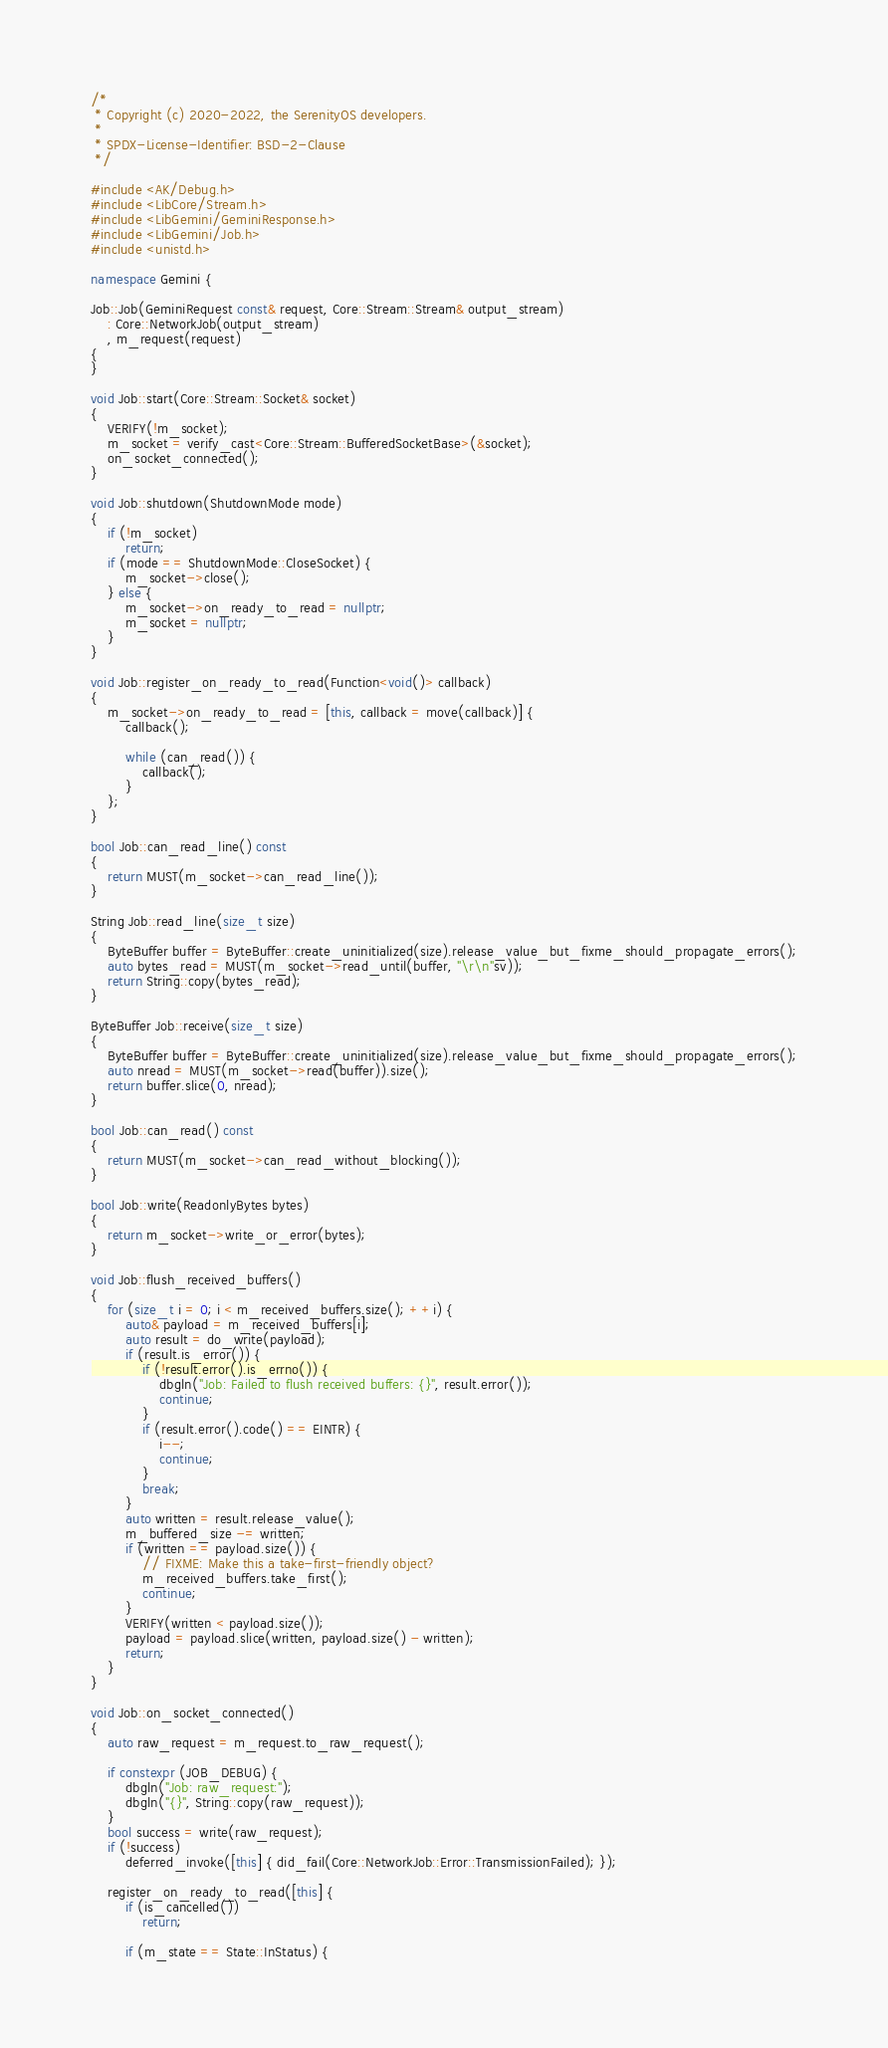<code> <loc_0><loc_0><loc_500><loc_500><_C++_>/*
 * Copyright (c) 2020-2022, the SerenityOS developers.
 *
 * SPDX-License-Identifier: BSD-2-Clause
 */

#include <AK/Debug.h>
#include <LibCore/Stream.h>
#include <LibGemini/GeminiResponse.h>
#include <LibGemini/Job.h>
#include <unistd.h>

namespace Gemini {

Job::Job(GeminiRequest const& request, Core::Stream::Stream& output_stream)
    : Core::NetworkJob(output_stream)
    , m_request(request)
{
}

void Job::start(Core::Stream::Socket& socket)
{
    VERIFY(!m_socket);
    m_socket = verify_cast<Core::Stream::BufferedSocketBase>(&socket);
    on_socket_connected();
}

void Job::shutdown(ShutdownMode mode)
{
    if (!m_socket)
        return;
    if (mode == ShutdownMode::CloseSocket) {
        m_socket->close();
    } else {
        m_socket->on_ready_to_read = nullptr;
        m_socket = nullptr;
    }
}

void Job::register_on_ready_to_read(Function<void()> callback)
{
    m_socket->on_ready_to_read = [this, callback = move(callback)] {
        callback();

        while (can_read()) {
            callback();
        }
    };
}

bool Job::can_read_line() const
{
    return MUST(m_socket->can_read_line());
}

String Job::read_line(size_t size)
{
    ByteBuffer buffer = ByteBuffer::create_uninitialized(size).release_value_but_fixme_should_propagate_errors();
    auto bytes_read = MUST(m_socket->read_until(buffer, "\r\n"sv));
    return String::copy(bytes_read);
}

ByteBuffer Job::receive(size_t size)
{
    ByteBuffer buffer = ByteBuffer::create_uninitialized(size).release_value_but_fixme_should_propagate_errors();
    auto nread = MUST(m_socket->read(buffer)).size();
    return buffer.slice(0, nread);
}

bool Job::can_read() const
{
    return MUST(m_socket->can_read_without_blocking());
}

bool Job::write(ReadonlyBytes bytes)
{
    return m_socket->write_or_error(bytes);
}

void Job::flush_received_buffers()
{
    for (size_t i = 0; i < m_received_buffers.size(); ++i) {
        auto& payload = m_received_buffers[i];
        auto result = do_write(payload);
        if (result.is_error()) {
            if (!result.error().is_errno()) {
                dbgln("Job: Failed to flush received buffers: {}", result.error());
                continue;
            }
            if (result.error().code() == EINTR) {
                i--;
                continue;
            }
            break;
        }
        auto written = result.release_value();
        m_buffered_size -= written;
        if (written == payload.size()) {
            // FIXME: Make this a take-first-friendly object?
            m_received_buffers.take_first();
            continue;
        }
        VERIFY(written < payload.size());
        payload = payload.slice(written, payload.size() - written);
        return;
    }
}

void Job::on_socket_connected()
{
    auto raw_request = m_request.to_raw_request();

    if constexpr (JOB_DEBUG) {
        dbgln("Job: raw_request:");
        dbgln("{}", String::copy(raw_request));
    }
    bool success = write(raw_request);
    if (!success)
        deferred_invoke([this] { did_fail(Core::NetworkJob::Error::TransmissionFailed); });

    register_on_ready_to_read([this] {
        if (is_cancelled())
            return;

        if (m_state == State::InStatus) {</code> 